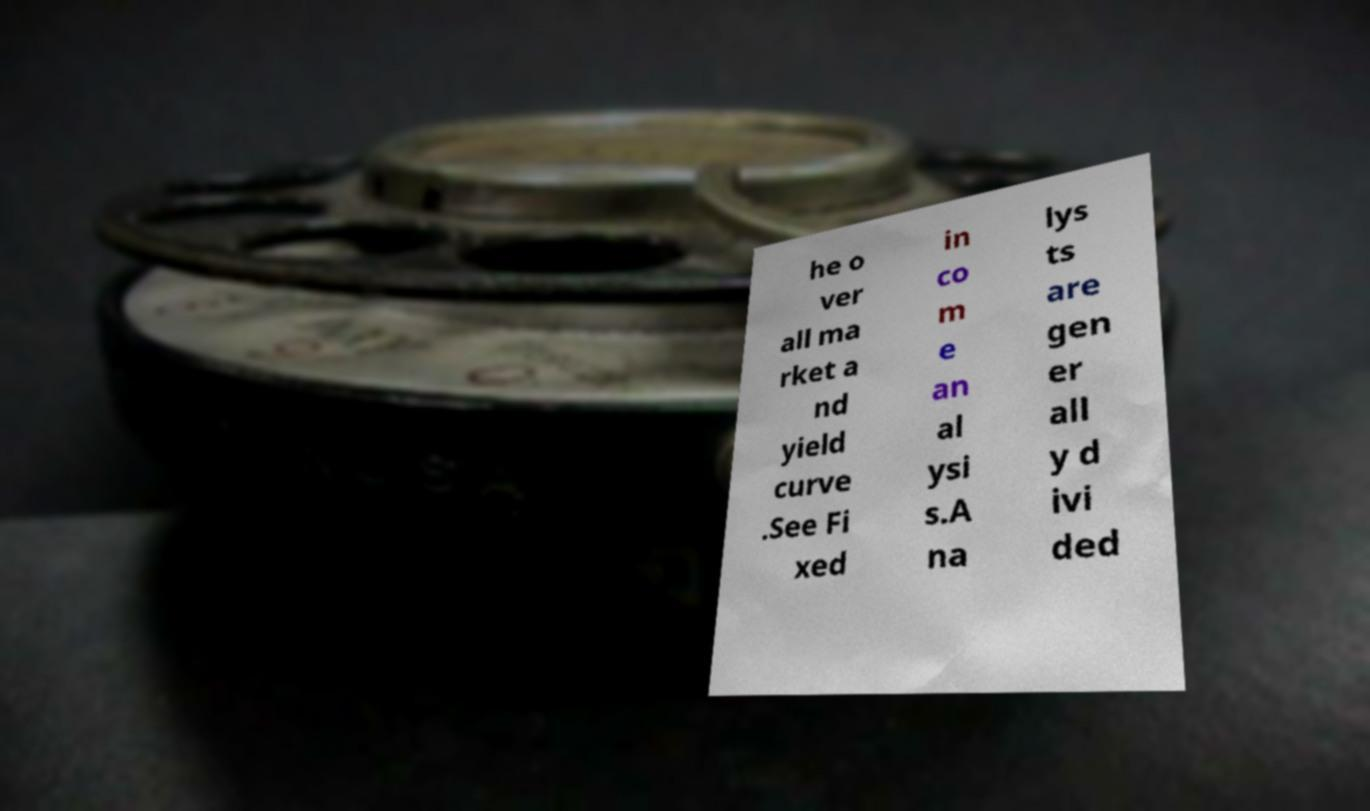Could you assist in decoding the text presented in this image and type it out clearly? he o ver all ma rket a nd yield curve .See Fi xed in co m e an al ysi s.A na lys ts are gen er all y d ivi ded 